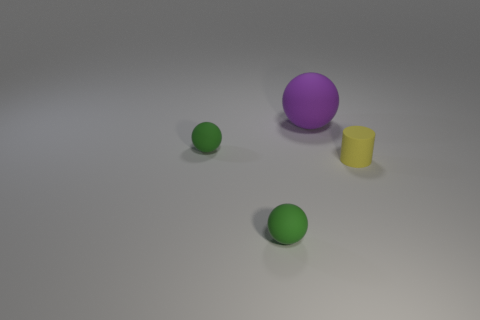Add 2 purple matte spheres. How many objects exist? 6 Subtract all cylinders. How many objects are left? 3 Subtract 1 purple spheres. How many objects are left? 3 Subtract all large things. Subtract all yellow rubber cylinders. How many objects are left? 2 Add 2 small green balls. How many small green balls are left? 4 Add 2 large purple matte objects. How many large purple matte objects exist? 3 